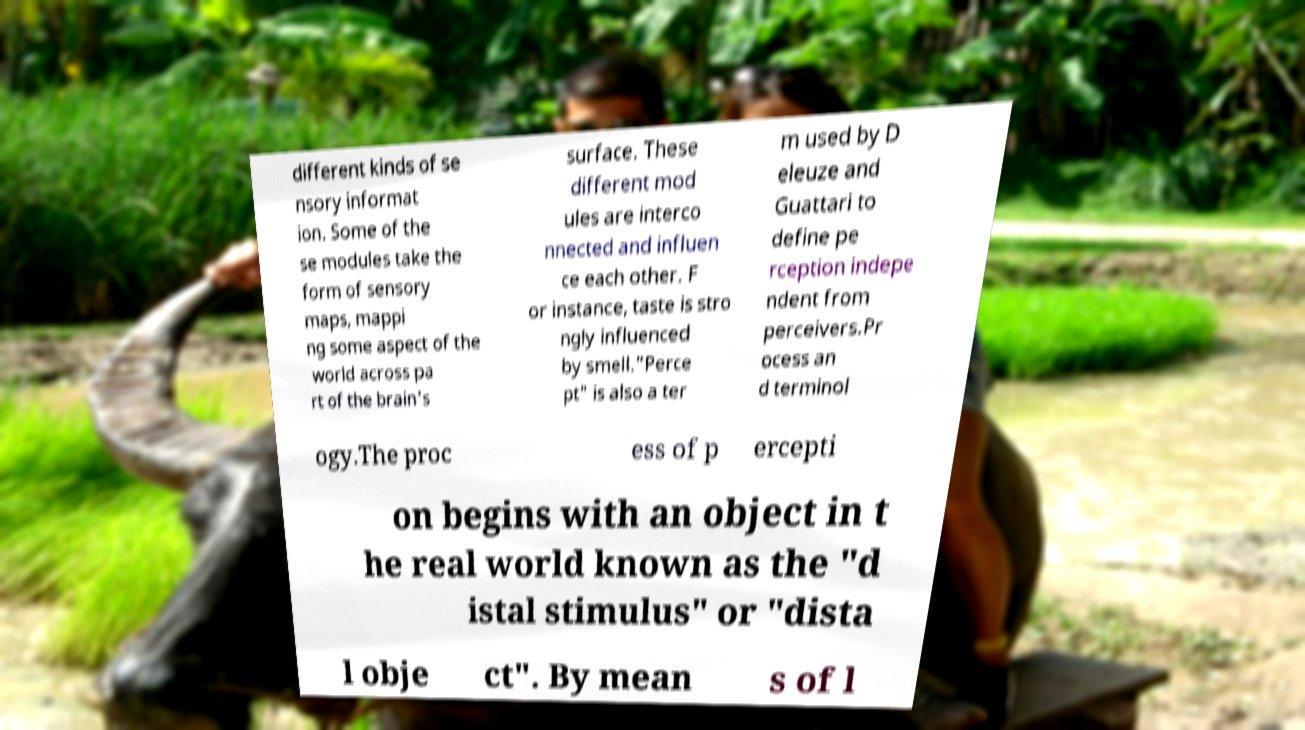Could you extract and type out the text from this image? different kinds of se nsory informat ion. Some of the se modules take the form of sensory maps, mappi ng some aspect of the world across pa rt of the brain's surface. These different mod ules are interco nnected and influen ce each other. F or instance, taste is stro ngly influenced by smell."Perce pt" is also a ter m used by D eleuze and Guattari to define pe rception indepe ndent from perceivers.Pr ocess an d terminol ogy.The proc ess of p ercepti on begins with an object in t he real world known as the "d istal stimulus" or "dista l obje ct". By mean s of l 